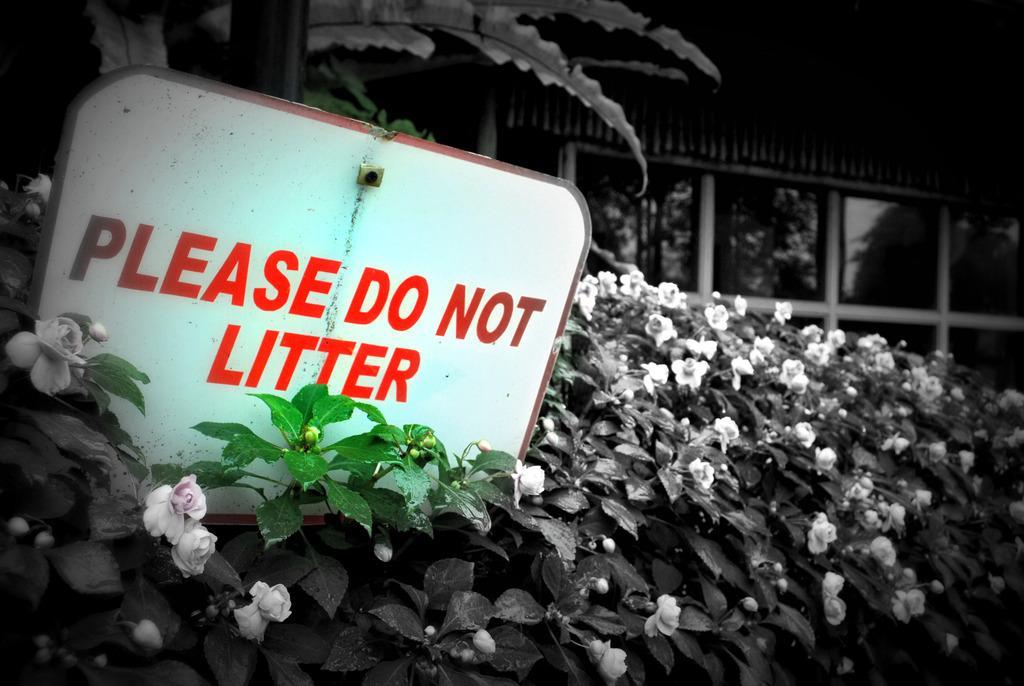Can you describe this image briefly? This is an edited image. In this picture there are plants, flowers, tree and a board. In the background there are trees, in the mirror and a building. 